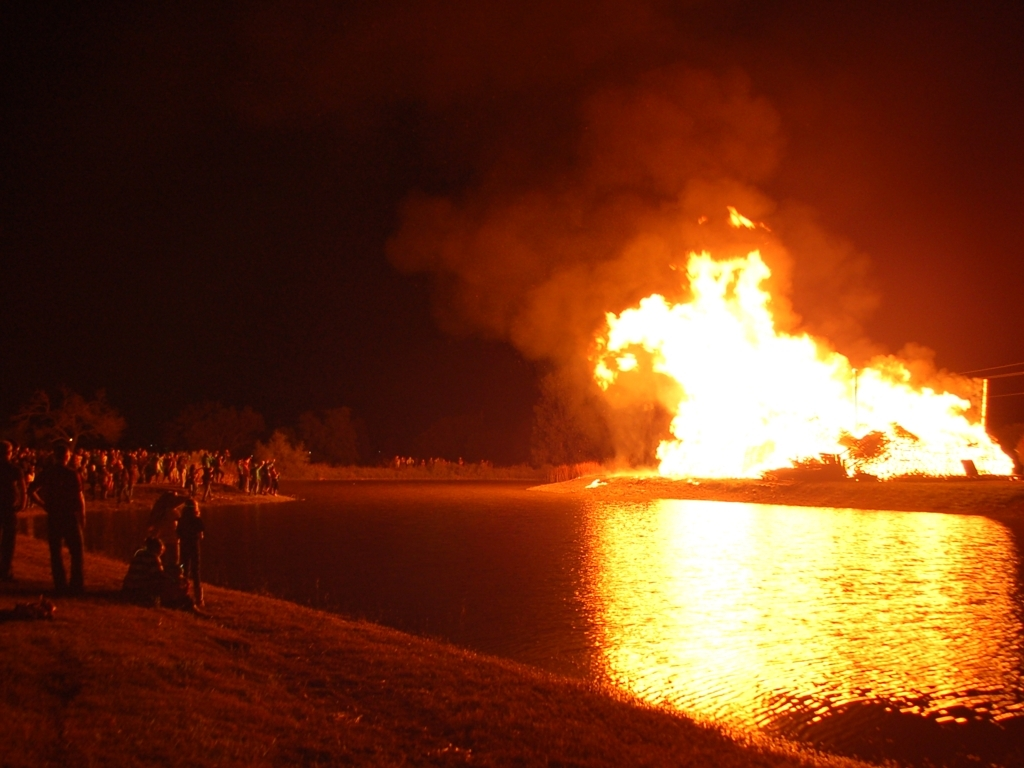Can you explain the reflections visible in the water? Certainly. The bright light from the flames is reflecting off the surface of the water, creating a mirror-like effect. The size of the reflection indicates that the fire is sizeable, and the calmness of the water allows for a clear reflection. 